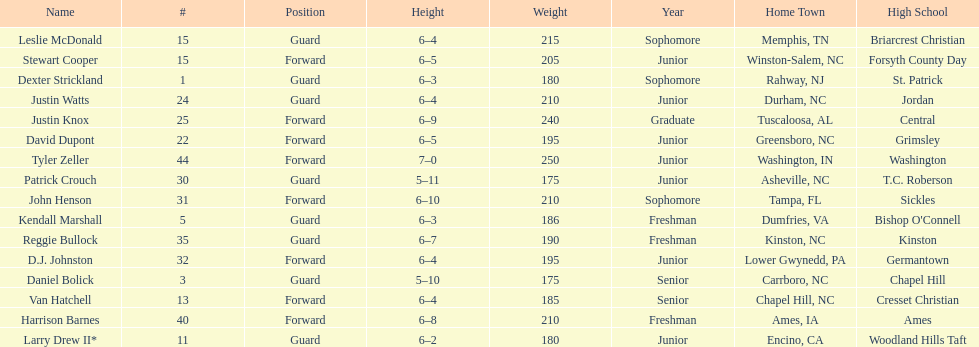Who was taller, justin knox or john henson? John Henson. 